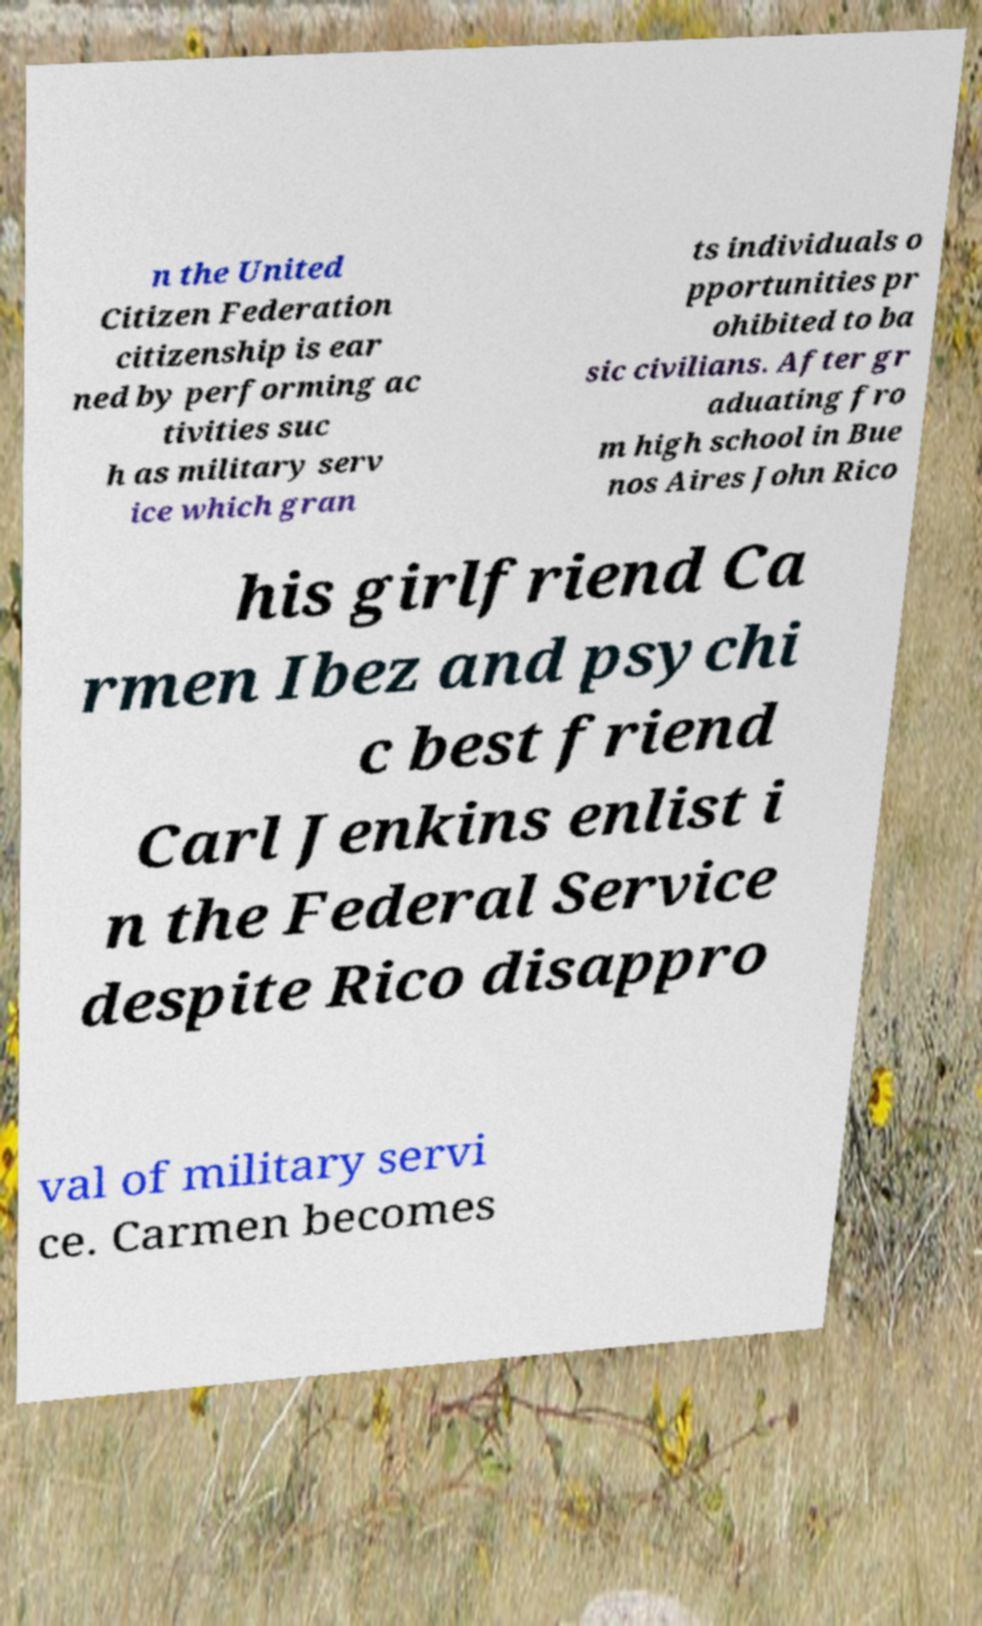Please read and relay the text visible in this image. What does it say? n the United Citizen Federation citizenship is ear ned by performing ac tivities suc h as military serv ice which gran ts individuals o pportunities pr ohibited to ba sic civilians. After gr aduating fro m high school in Bue nos Aires John Rico his girlfriend Ca rmen Ibez and psychi c best friend Carl Jenkins enlist i n the Federal Service despite Rico disappro val of military servi ce. Carmen becomes 